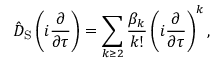<formula> <loc_0><loc_0><loc_500><loc_500>\hat { D } _ { S } \left ( i \frac { \partial } { \partial \tau } \right ) = \sum _ { k \geq 2 } \frac { \beta _ { k } } { k ! } \left ( i \frac { \partial } { \partial \tau } \right ) ^ { k } ,</formula> 